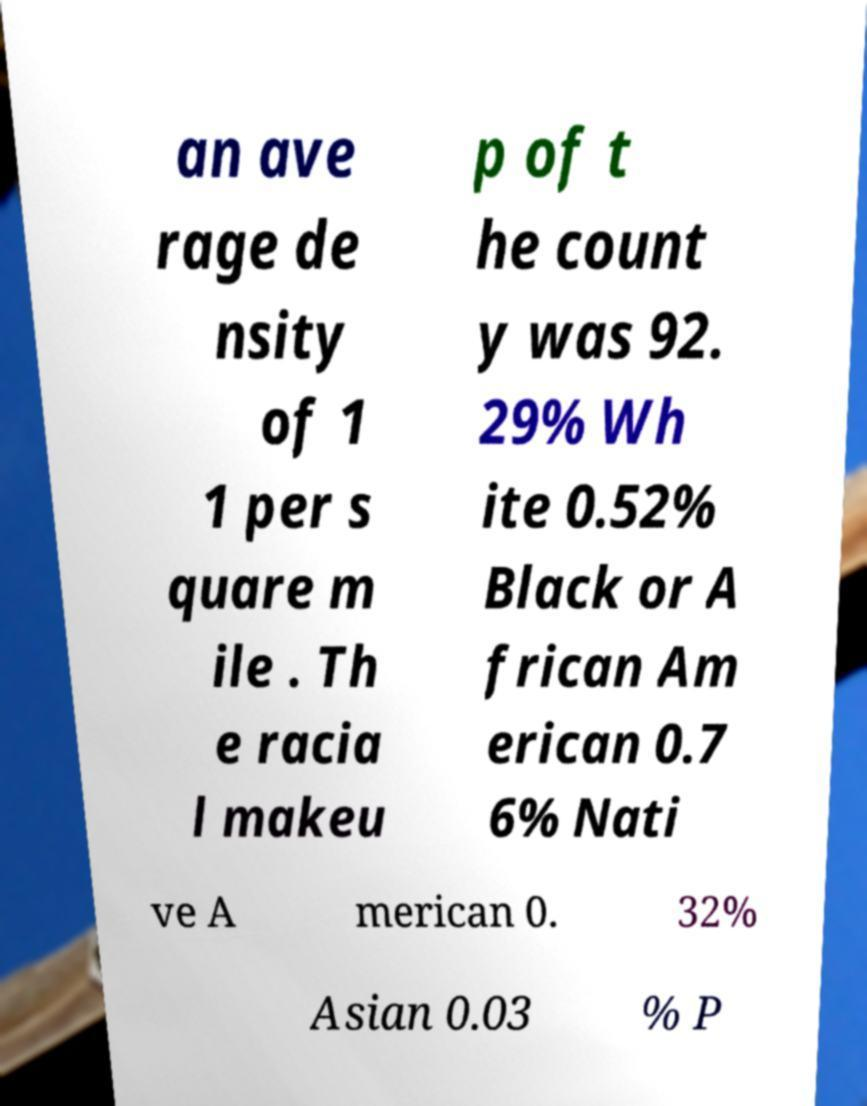Could you extract and type out the text from this image? an ave rage de nsity of 1 1 per s quare m ile . Th e racia l makeu p of t he count y was 92. 29% Wh ite 0.52% Black or A frican Am erican 0.7 6% Nati ve A merican 0. 32% Asian 0.03 % P 